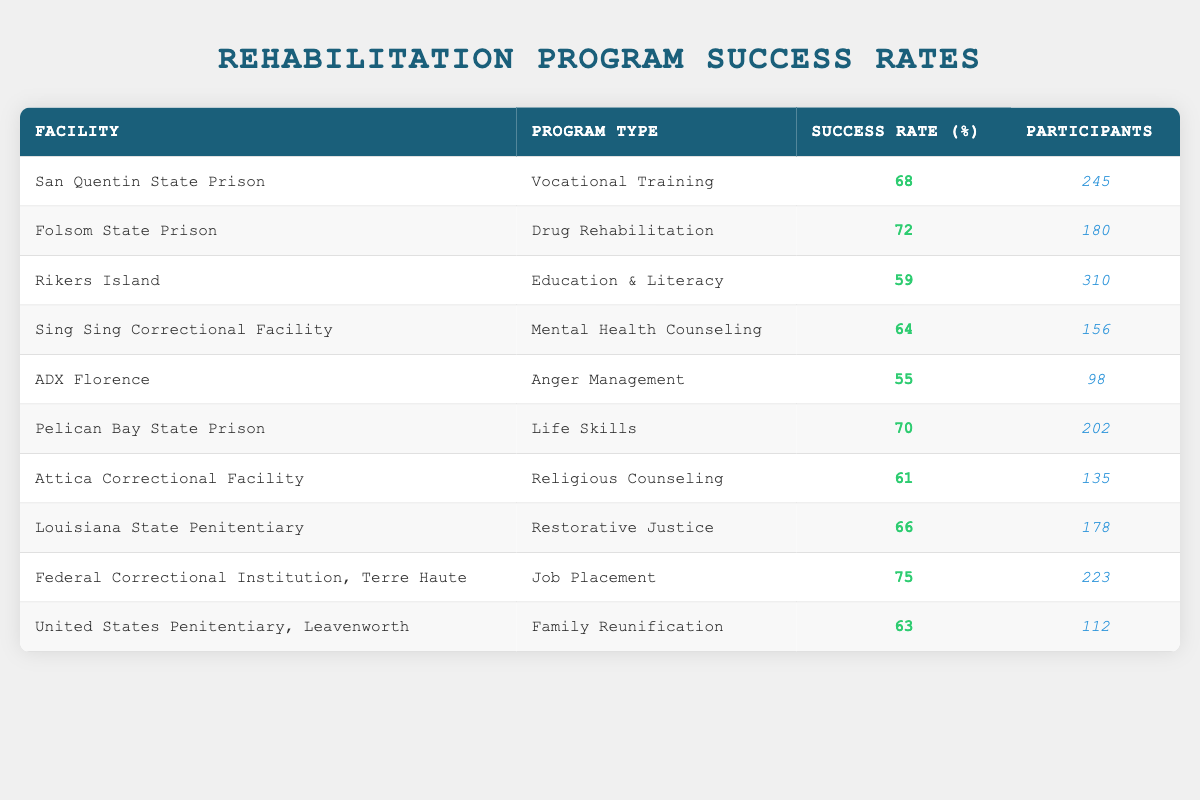What is the success rate of the rehabilitation program at Folsom State Prison? The table lists Folsom State Prison under the "Facility" column, with its corresponding success rate shown in the "Success Rate (%)" column as 72.
Answer: 72 Which facility has the highest success rate? The highest success rate in the table is listed under the "Federal Correctional Institution, Terre Haute," where the success rate is 75%.
Answer: 75 What is the average success rate of all facilities listed? To find the average, I will sum all success rates (68 + 72 + 59 + 64 + 55 + 70 + 61 + 66 + 75 + 63 =  681) and divide by the number of facilities (10). The average is 681 / 10 = 68.1.
Answer: 68.1 Is the success rate of Mental Health Counseling higher than that of Anger Management? Mental Health Counseling at Sing Sing Correctional Facility has a success rate of 64%, while Anger Management at ADX Florence has a lower rate of 55%. Hence, the statement is true.
Answer: Yes What is the total number of participants in all programs? To calculate the total participants, I will sum up each facility's participant counts: (245 + 180 + 310 + 156 + 98 + 202 + 135 + 178 + 223 + 112 = 1884). Thus, the total number of participants is 1884.
Answer: 1884 Which program type had the lowest success rate, and what was it? By examining the "Success Rate (%)" column, the lowest value is 55, which corresponds to the "Anger Management" program listed for ADX Florence.
Answer: Anger Management, 55 Are there more participants in the Education & Literacy program compared to the Vocational Training program? The table shows that the Education & Literacy program has 310 participants, while the Vocational Training program has 245 participants. Since 310 is greater than 245, the statement is true.
Answer: Yes What is the difference in success rates between the Drug Rehabilitation program and the Life Skills program? The success rate for Drug Rehabilitation at Folsom State Prison is 72%, and for Life Skills at Pelican Bay State Prison, it is 70%. The difference is calculated as 72 - 70 = 2.
Answer: 2 Which facilities have a success rate below 60%? The table shows Rikers Island with 59% and ADX Florence with 55%. Thus, both facilities have success rates below 60%.
Answer: Rikers Island, ADX Florence 